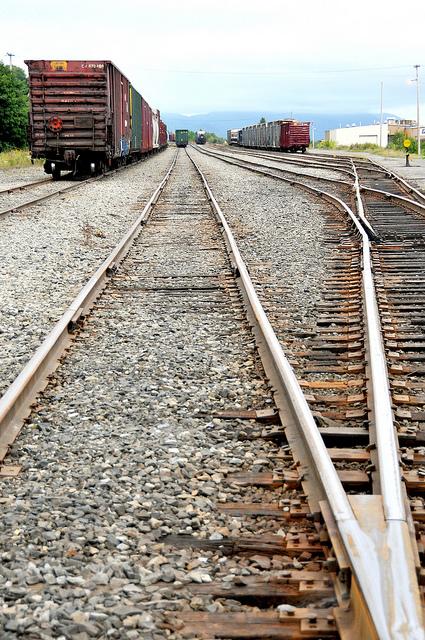What is on the railroad tracks?
Be succinct. Trains. Are these freight cars?
Concise answer only. Yes. Why are there rocks in between the tracks?
Be succinct. Fill space. 